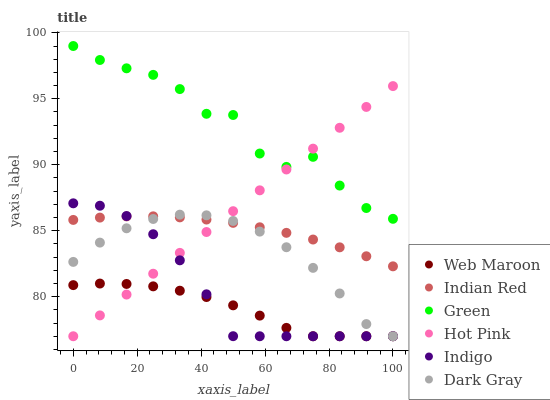Does Web Maroon have the minimum area under the curve?
Answer yes or no. Yes. Does Green have the maximum area under the curve?
Answer yes or no. Yes. Does Hot Pink have the minimum area under the curve?
Answer yes or no. No. Does Hot Pink have the maximum area under the curve?
Answer yes or no. No. Is Hot Pink the smoothest?
Answer yes or no. Yes. Is Green the roughest?
Answer yes or no. Yes. Is Web Maroon the smoothest?
Answer yes or no. No. Is Web Maroon the roughest?
Answer yes or no. No. Does Indigo have the lowest value?
Answer yes or no. Yes. Does Green have the lowest value?
Answer yes or no. No. Does Green have the highest value?
Answer yes or no. Yes. Does Hot Pink have the highest value?
Answer yes or no. No. Is Indian Red less than Green?
Answer yes or no. Yes. Is Green greater than Indigo?
Answer yes or no. Yes. Does Indigo intersect Dark Gray?
Answer yes or no. Yes. Is Indigo less than Dark Gray?
Answer yes or no. No. Is Indigo greater than Dark Gray?
Answer yes or no. No. Does Indian Red intersect Green?
Answer yes or no. No. 